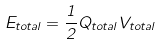Convert formula to latex. <formula><loc_0><loc_0><loc_500><loc_500>E _ { t o t a l } = \frac { 1 } { 2 } Q _ { t o t a l } V _ { t o t a l }</formula> 